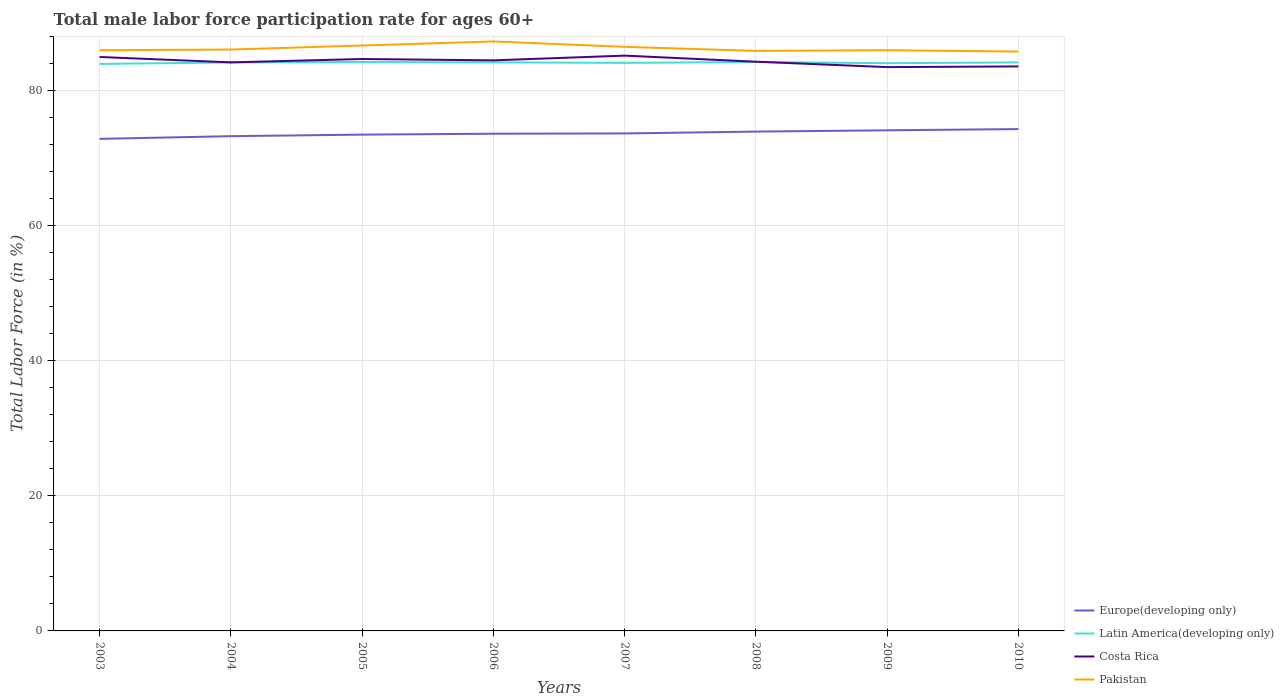How many different coloured lines are there?
Offer a very short reply. 4. Is the number of lines equal to the number of legend labels?
Your answer should be compact. Yes. Across all years, what is the maximum male labor force participation rate in Costa Rica?
Offer a terse response. 83.5. In which year was the male labor force participation rate in Europe(developing only) maximum?
Make the answer very short. 2003. What is the total male labor force participation rate in Pakistan in the graph?
Offer a very short reply. -0.1. What is the difference between the highest and the second highest male labor force participation rate in Latin America(developing only)?
Your answer should be very brief. 0.28. What is the difference between the highest and the lowest male labor force participation rate in Latin America(developing only)?
Provide a succinct answer. 5. Is the male labor force participation rate in Pakistan strictly greater than the male labor force participation rate in Latin America(developing only) over the years?
Give a very brief answer. No. How many lines are there?
Keep it short and to the point. 4. How many years are there in the graph?
Provide a succinct answer. 8. Are the values on the major ticks of Y-axis written in scientific E-notation?
Offer a terse response. No. Does the graph contain grids?
Provide a succinct answer. Yes. Where does the legend appear in the graph?
Provide a succinct answer. Bottom right. What is the title of the graph?
Your response must be concise. Total male labor force participation rate for ages 60+. Does "Europe(all income levels)" appear as one of the legend labels in the graph?
Keep it short and to the point. No. What is the label or title of the Y-axis?
Keep it short and to the point. Total Labor Force (in %). What is the Total Labor Force (in %) in Europe(developing only) in 2003?
Provide a succinct answer. 72.87. What is the Total Labor Force (in %) of Latin America(developing only) in 2003?
Keep it short and to the point. 83.97. What is the Total Labor Force (in %) in Costa Rica in 2003?
Offer a terse response. 85. What is the Total Labor Force (in %) in Europe(developing only) in 2004?
Your answer should be very brief. 73.27. What is the Total Labor Force (in %) of Latin America(developing only) in 2004?
Provide a short and direct response. 84.19. What is the Total Labor Force (in %) in Costa Rica in 2004?
Keep it short and to the point. 84.2. What is the Total Labor Force (in %) in Pakistan in 2004?
Provide a short and direct response. 86.1. What is the Total Labor Force (in %) in Europe(developing only) in 2005?
Provide a succinct answer. 73.5. What is the Total Labor Force (in %) of Latin America(developing only) in 2005?
Keep it short and to the point. 84.25. What is the Total Labor Force (in %) of Costa Rica in 2005?
Make the answer very short. 84.7. What is the Total Labor Force (in %) in Pakistan in 2005?
Your answer should be compact. 86.7. What is the Total Labor Force (in %) in Europe(developing only) in 2006?
Keep it short and to the point. 73.63. What is the Total Labor Force (in %) of Latin America(developing only) in 2006?
Ensure brevity in your answer.  84.2. What is the Total Labor Force (in %) of Costa Rica in 2006?
Make the answer very short. 84.5. What is the Total Labor Force (in %) of Pakistan in 2006?
Your answer should be compact. 87.3. What is the Total Labor Force (in %) in Europe(developing only) in 2007?
Provide a succinct answer. 73.68. What is the Total Labor Force (in %) of Latin America(developing only) in 2007?
Keep it short and to the point. 84.13. What is the Total Labor Force (in %) in Costa Rica in 2007?
Give a very brief answer. 85.2. What is the Total Labor Force (in %) of Pakistan in 2007?
Provide a succinct answer. 86.5. What is the Total Labor Force (in %) of Europe(developing only) in 2008?
Offer a terse response. 73.95. What is the Total Labor Force (in %) of Latin America(developing only) in 2008?
Ensure brevity in your answer.  84.26. What is the Total Labor Force (in %) in Costa Rica in 2008?
Provide a short and direct response. 84.3. What is the Total Labor Force (in %) of Pakistan in 2008?
Your answer should be compact. 85.9. What is the Total Labor Force (in %) of Europe(developing only) in 2009?
Provide a succinct answer. 74.14. What is the Total Labor Force (in %) in Latin America(developing only) in 2009?
Offer a terse response. 84.08. What is the Total Labor Force (in %) of Costa Rica in 2009?
Make the answer very short. 83.5. What is the Total Labor Force (in %) in Europe(developing only) in 2010?
Keep it short and to the point. 74.32. What is the Total Labor Force (in %) of Latin America(developing only) in 2010?
Make the answer very short. 84.2. What is the Total Labor Force (in %) of Costa Rica in 2010?
Make the answer very short. 83.6. What is the Total Labor Force (in %) of Pakistan in 2010?
Ensure brevity in your answer.  85.8. Across all years, what is the maximum Total Labor Force (in %) in Europe(developing only)?
Offer a terse response. 74.32. Across all years, what is the maximum Total Labor Force (in %) of Latin America(developing only)?
Ensure brevity in your answer.  84.26. Across all years, what is the maximum Total Labor Force (in %) of Costa Rica?
Offer a very short reply. 85.2. Across all years, what is the maximum Total Labor Force (in %) in Pakistan?
Your response must be concise. 87.3. Across all years, what is the minimum Total Labor Force (in %) in Europe(developing only)?
Your answer should be compact. 72.87. Across all years, what is the minimum Total Labor Force (in %) in Latin America(developing only)?
Provide a short and direct response. 83.97. Across all years, what is the minimum Total Labor Force (in %) of Costa Rica?
Make the answer very short. 83.5. Across all years, what is the minimum Total Labor Force (in %) of Pakistan?
Ensure brevity in your answer.  85.8. What is the total Total Labor Force (in %) of Europe(developing only) in the graph?
Your answer should be compact. 589.37. What is the total Total Labor Force (in %) of Latin America(developing only) in the graph?
Ensure brevity in your answer.  673.28. What is the total Total Labor Force (in %) in Costa Rica in the graph?
Provide a short and direct response. 675. What is the total Total Labor Force (in %) in Pakistan in the graph?
Ensure brevity in your answer.  690.3. What is the difference between the Total Labor Force (in %) in Europe(developing only) in 2003 and that in 2004?
Your response must be concise. -0.4. What is the difference between the Total Labor Force (in %) of Latin America(developing only) in 2003 and that in 2004?
Give a very brief answer. -0.22. What is the difference between the Total Labor Force (in %) in Europe(developing only) in 2003 and that in 2005?
Ensure brevity in your answer.  -0.63. What is the difference between the Total Labor Force (in %) of Latin America(developing only) in 2003 and that in 2005?
Your answer should be very brief. -0.28. What is the difference between the Total Labor Force (in %) in Costa Rica in 2003 and that in 2005?
Provide a short and direct response. 0.3. What is the difference between the Total Labor Force (in %) of Pakistan in 2003 and that in 2005?
Provide a succinct answer. -0.7. What is the difference between the Total Labor Force (in %) of Europe(developing only) in 2003 and that in 2006?
Give a very brief answer. -0.76. What is the difference between the Total Labor Force (in %) in Latin America(developing only) in 2003 and that in 2006?
Offer a very short reply. -0.23. What is the difference between the Total Labor Force (in %) in Pakistan in 2003 and that in 2006?
Provide a short and direct response. -1.3. What is the difference between the Total Labor Force (in %) of Europe(developing only) in 2003 and that in 2007?
Offer a very short reply. -0.8. What is the difference between the Total Labor Force (in %) in Latin America(developing only) in 2003 and that in 2007?
Offer a very short reply. -0.15. What is the difference between the Total Labor Force (in %) in Costa Rica in 2003 and that in 2007?
Give a very brief answer. -0.2. What is the difference between the Total Labor Force (in %) of Europe(developing only) in 2003 and that in 2008?
Offer a very short reply. -1.08. What is the difference between the Total Labor Force (in %) of Latin America(developing only) in 2003 and that in 2008?
Make the answer very short. -0.28. What is the difference between the Total Labor Force (in %) in Costa Rica in 2003 and that in 2008?
Give a very brief answer. 0.7. What is the difference between the Total Labor Force (in %) of Europe(developing only) in 2003 and that in 2009?
Give a very brief answer. -1.27. What is the difference between the Total Labor Force (in %) of Latin America(developing only) in 2003 and that in 2009?
Make the answer very short. -0.11. What is the difference between the Total Labor Force (in %) of Costa Rica in 2003 and that in 2009?
Provide a short and direct response. 1.5. What is the difference between the Total Labor Force (in %) in Europe(developing only) in 2003 and that in 2010?
Make the answer very short. -1.45. What is the difference between the Total Labor Force (in %) in Latin America(developing only) in 2003 and that in 2010?
Offer a terse response. -0.22. What is the difference between the Total Labor Force (in %) of Pakistan in 2003 and that in 2010?
Keep it short and to the point. 0.2. What is the difference between the Total Labor Force (in %) of Europe(developing only) in 2004 and that in 2005?
Your answer should be compact. -0.23. What is the difference between the Total Labor Force (in %) of Latin America(developing only) in 2004 and that in 2005?
Your answer should be very brief. -0.06. What is the difference between the Total Labor Force (in %) in Costa Rica in 2004 and that in 2005?
Provide a succinct answer. -0.5. What is the difference between the Total Labor Force (in %) in Europe(developing only) in 2004 and that in 2006?
Keep it short and to the point. -0.36. What is the difference between the Total Labor Force (in %) of Latin America(developing only) in 2004 and that in 2006?
Give a very brief answer. -0.01. What is the difference between the Total Labor Force (in %) in Pakistan in 2004 and that in 2006?
Provide a short and direct response. -1.2. What is the difference between the Total Labor Force (in %) in Europe(developing only) in 2004 and that in 2007?
Keep it short and to the point. -0.4. What is the difference between the Total Labor Force (in %) of Latin America(developing only) in 2004 and that in 2007?
Your answer should be compact. 0.06. What is the difference between the Total Labor Force (in %) in Europe(developing only) in 2004 and that in 2008?
Give a very brief answer. -0.68. What is the difference between the Total Labor Force (in %) in Latin America(developing only) in 2004 and that in 2008?
Your answer should be very brief. -0.07. What is the difference between the Total Labor Force (in %) in Europe(developing only) in 2004 and that in 2009?
Provide a short and direct response. -0.87. What is the difference between the Total Labor Force (in %) in Latin America(developing only) in 2004 and that in 2009?
Offer a very short reply. 0.11. What is the difference between the Total Labor Force (in %) of Costa Rica in 2004 and that in 2009?
Provide a short and direct response. 0.7. What is the difference between the Total Labor Force (in %) of Europe(developing only) in 2004 and that in 2010?
Your response must be concise. -1.05. What is the difference between the Total Labor Force (in %) in Latin America(developing only) in 2004 and that in 2010?
Your response must be concise. -0.01. What is the difference between the Total Labor Force (in %) of Pakistan in 2004 and that in 2010?
Your answer should be compact. 0.3. What is the difference between the Total Labor Force (in %) in Europe(developing only) in 2005 and that in 2006?
Make the answer very short. -0.13. What is the difference between the Total Labor Force (in %) in Latin America(developing only) in 2005 and that in 2006?
Provide a succinct answer. 0.05. What is the difference between the Total Labor Force (in %) in Costa Rica in 2005 and that in 2006?
Give a very brief answer. 0.2. What is the difference between the Total Labor Force (in %) of Europe(developing only) in 2005 and that in 2007?
Your response must be concise. -0.17. What is the difference between the Total Labor Force (in %) in Latin America(developing only) in 2005 and that in 2007?
Keep it short and to the point. 0.13. What is the difference between the Total Labor Force (in %) in Europe(developing only) in 2005 and that in 2008?
Ensure brevity in your answer.  -0.45. What is the difference between the Total Labor Force (in %) in Latin America(developing only) in 2005 and that in 2008?
Make the answer very short. -0. What is the difference between the Total Labor Force (in %) in Pakistan in 2005 and that in 2008?
Your answer should be compact. 0.8. What is the difference between the Total Labor Force (in %) in Europe(developing only) in 2005 and that in 2009?
Offer a terse response. -0.64. What is the difference between the Total Labor Force (in %) of Latin America(developing only) in 2005 and that in 2009?
Your response must be concise. 0.17. What is the difference between the Total Labor Force (in %) of Pakistan in 2005 and that in 2009?
Offer a terse response. 0.7. What is the difference between the Total Labor Force (in %) in Europe(developing only) in 2005 and that in 2010?
Offer a very short reply. -0.82. What is the difference between the Total Labor Force (in %) of Latin America(developing only) in 2005 and that in 2010?
Ensure brevity in your answer.  0.06. What is the difference between the Total Labor Force (in %) of Costa Rica in 2005 and that in 2010?
Ensure brevity in your answer.  1.1. What is the difference between the Total Labor Force (in %) of Pakistan in 2005 and that in 2010?
Keep it short and to the point. 0.9. What is the difference between the Total Labor Force (in %) in Europe(developing only) in 2006 and that in 2007?
Offer a terse response. -0.04. What is the difference between the Total Labor Force (in %) of Latin America(developing only) in 2006 and that in 2007?
Ensure brevity in your answer.  0.08. What is the difference between the Total Labor Force (in %) of Pakistan in 2006 and that in 2007?
Provide a short and direct response. 0.8. What is the difference between the Total Labor Force (in %) in Europe(developing only) in 2006 and that in 2008?
Provide a succinct answer. -0.32. What is the difference between the Total Labor Force (in %) in Latin America(developing only) in 2006 and that in 2008?
Offer a very short reply. -0.05. What is the difference between the Total Labor Force (in %) of Pakistan in 2006 and that in 2008?
Offer a terse response. 1.4. What is the difference between the Total Labor Force (in %) in Europe(developing only) in 2006 and that in 2009?
Keep it short and to the point. -0.51. What is the difference between the Total Labor Force (in %) of Latin America(developing only) in 2006 and that in 2009?
Keep it short and to the point. 0.12. What is the difference between the Total Labor Force (in %) in Pakistan in 2006 and that in 2009?
Your answer should be very brief. 1.3. What is the difference between the Total Labor Force (in %) in Europe(developing only) in 2006 and that in 2010?
Make the answer very short. -0.69. What is the difference between the Total Labor Force (in %) in Latin America(developing only) in 2006 and that in 2010?
Keep it short and to the point. 0.01. What is the difference between the Total Labor Force (in %) in Europe(developing only) in 2007 and that in 2008?
Provide a succinct answer. -0.27. What is the difference between the Total Labor Force (in %) in Latin America(developing only) in 2007 and that in 2008?
Keep it short and to the point. -0.13. What is the difference between the Total Labor Force (in %) of Costa Rica in 2007 and that in 2008?
Your response must be concise. 0.9. What is the difference between the Total Labor Force (in %) of Pakistan in 2007 and that in 2008?
Offer a terse response. 0.6. What is the difference between the Total Labor Force (in %) of Europe(developing only) in 2007 and that in 2009?
Provide a succinct answer. -0.47. What is the difference between the Total Labor Force (in %) in Latin America(developing only) in 2007 and that in 2009?
Your answer should be very brief. 0.05. What is the difference between the Total Labor Force (in %) in Costa Rica in 2007 and that in 2009?
Your response must be concise. 1.7. What is the difference between the Total Labor Force (in %) in Europe(developing only) in 2007 and that in 2010?
Provide a succinct answer. -0.64. What is the difference between the Total Labor Force (in %) of Latin America(developing only) in 2007 and that in 2010?
Make the answer very short. -0.07. What is the difference between the Total Labor Force (in %) in Pakistan in 2007 and that in 2010?
Give a very brief answer. 0.7. What is the difference between the Total Labor Force (in %) of Europe(developing only) in 2008 and that in 2009?
Ensure brevity in your answer.  -0.19. What is the difference between the Total Labor Force (in %) in Latin America(developing only) in 2008 and that in 2009?
Your response must be concise. 0.18. What is the difference between the Total Labor Force (in %) of Costa Rica in 2008 and that in 2009?
Offer a very short reply. 0.8. What is the difference between the Total Labor Force (in %) of Pakistan in 2008 and that in 2009?
Keep it short and to the point. -0.1. What is the difference between the Total Labor Force (in %) in Europe(developing only) in 2008 and that in 2010?
Your answer should be compact. -0.37. What is the difference between the Total Labor Force (in %) of Latin America(developing only) in 2008 and that in 2010?
Make the answer very short. 0.06. What is the difference between the Total Labor Force (in %) in Pakistan in 2008 and that in 2010?
Provide a short and direct response. 0.1. What is the difference between the Total Labor Force (in %) of Europe(developing only) in 2009 and that in 2010?
Your answer should be compact. -0.18. What is the difference between the Total Labor Force (in %) in Latin America(developing only) in 2009 and that in 2010?
Make the answer very short. -0.12. What is the difference between the Total Labor Force (in %) of Costa Rica in 2009 and that in 2010?
Offer a terse response. -0.1. What is the difference between the Total Labor Force (in %) in Europe(developing only) in 2003 and the Total Labor Force (in %) in Latin America(developing only) in 2004?
Provide a succinct answer. -11.32. What is the difference between the Total Labor Force (in %) of Europe(developing only) in 2003 and the Total Labor Force (in %) of Costa Rica in 2004?
Your answer should be compact. -11.33. What is the difference between the Total Labor Force (in %) in Europe(developing only) in 2003 and the Total Labor Force (in %) in Pakistan in 2004?
Offer a terse response. -13.23. What is the difference between the Total Labor Force (in %) of Latin America(developing only) in 2003 and the Total Labor Force (in %) of Costa Rica in 2004?
Your response must be concise. -0.23. What is the difference between the Total Labor Force (in %) of Latin America(developing only) in 2003 and the Total Labor Force (in %) of Pakistan in 2004?
Provide a short and direct response. -2.13. What is the difference between the Total Labor Force (in %) in Costa Rica in 2003 and the Total Labor Force (in %) in Pakistan in 2004?
Your answer should be compact. -1.1. What is the difference between the Total Labor Force (in %) in Europe(developing only) in 2003 and the Total Labor Force (in %) in Latin America(developing only) in 2005?
Your response must be concise. -11.38. What is the difference between the Total Labor Force (in %) in Europe(developing only) in 2003 and the Total Labor Force (in %) in Costa Rica in 2005?
Your answer should be very brief. -11.83. What is the difference between the Total Labor Force (in %) in Europe(developing only) in 2003 and the Total Labor Force (in %) in Pakistan in 2005?
Ensure brevity in your answer.  -13.83. What is the difference between the Total Labor Force (in %) of Latin America(developing only) in 2003 and the Total Labor Force (in %) of Costa Rica in 2005?
Make the answer very short. -0.73. What is the difference between the Total Labor Force (in %) in Latin America(developing only) in 2003 and the Total Labor Force (in %) in Pakistan in 2005?
Keep it short and to the point. -2.73. What is the difference between the Total Labor Force (in %) of Europe(developing only) in 2003 and the Total Labor Force (in %) of Latin America(developing only) in 2006?
Your response must be concise. -11.33. What is the difference between the Total Labor Force (in %) in Europe(developing only) in 2003 and the Total Labor Force (in %) in Costa Rica in 2006?
Offer a very short reply. -11.63. What is the difference between the Total Labor Force (in %) of Europe(developing only) in 2003 and the Total Labor Force (in %) of Pakistan in 2006?
Ensure brevity in your answer.  -14.43. What is the difference between the Total Labor Force (in %) in Latin America(developing only) in 2003 and the Total Labor Force (in %) in Costa Rica in 2006?
Your answer should be very brief. -0.53. What is the difference between the Total Labor Force (in %) of Latin America(developing only) in 2003 and the Total Labor Force (in %) of Pakistan in 2006?
Provide a succinct answer. -3.33. What is the difference between the Total Labor Force (in %) in Europe(developing only) in 2003 and the Total Labor Force (in %) in Latin America(developing only) in 2007?
Keep it short and to the point. -11.25. What is the difference between the Total Labor Force (in %) in Europe(developing only) in 2003 and the Total Labor Force (in %) in Costa Rica in 2007?
Keep it short and to the point. -12.33. What is the difference between the Total Labor Force (in %) in Europe(developing only) in 2003 and the Total Labor Force (in %) in Pakistan in 2007?
Make the answer very short. -13.63. What is the difference between the Total Labor Force (in %) of Latin America(developing only) in 2003 and the Total Labor Force (in %) of Costa Rica in 2007?
Make the answer very short. -1.23. What is the difference between the Total Labor Force (in %) of Latin America(developing only) in 2003 and the Total Labor Force (in %) of Pakistan in 2007?
Provide a short and direct response. -2.53. What is the difference between the Total Labor Force (in %) of Europe(developing only) in 2003 and the Total Labor Force (in %) of Latin America(developing only) in 2008?
Offer a very short reply. -11.38. What is the difference between the Total Labor Force (in %) of Europe(developing only) in 2003 and the Total Labor Force (in %) of Costa Rica in 2008?
Make the answer very short. -11.43. What is the difference between the Total Labor Force (in %) of Europe(developing only) in 2003 and the Total Labor Force (in %) of Pakistan in 2008?
Your answer should be very brief. -13.03. What is the difference between the Total Labor Force (in %) in Latin America(developing only) in 2003 and the Total Labor Force (in %) in Costa Rica in 2008?
Your answer should be very brief. -0.33. What is the difference between the Total Labor Force (in %) in Latin America(developing only) in 2003 and the Total Labor Force (in %) in Pakistan in 2008?
Your answer should be very brief. -1.93. What is the difference between the Total Labor Force (in %) of Costa Rica in 2003 and the Total Labor Force (in %) of Pakistan in 2008?
Your answer should be very brief. -0.9. What is the difference between the Total Labor Force (in %) in Europe(developing only) in 2003 and the Total Labor Force (in %) in Latin America(developing only) in 2009?
Give a very brief answer. -11.21. What is the difference between the Total Labor Force (in %) in Europe(developing only) in 2003 and the Total Labor Force (in %) in Costa Rica in 2009?
Ensure brevity in your answer.  -10.63. What is the difference between the Total Labor Force (in %) in Europe(developing only) in 2003 and the Total Labor Force (in %) in Pakistan in 2009?
Provide a short and direct response. -13.13. What is the difference between the Total Labor Force (in %) in Latin America(developing only) in 2003 and the Total Labor Force (in %) in Costa Rica in 2009?
Your response must be concise. 0.47. What is the difference between the Total Labor Force (in %) of Latin America(developing only) in 2003 and the Total Labor Force (in %) of Pakistan in 2009?
Give a very brief answer. -2.03. What is the difference between the Total Labor Force (in %) of Europe(developing only) in 2003 and the Total Labor Force (in %) of Latin America(developing only) in 2010?
Offer a very short reply. -11.32. What is the difference between the Total Labor Force (in %) in Europe(developing only) in 2003 and the Total Labor Force (in %) in Costa Rica in 2010?
Make the answer very short. -10.73. What is the difference between the Total Labor Force (in %) in Europe(developing only) in 2003 and the Total Labor Force (in %) in Pakistan in 2010?
Your answer should be very brief. -12.93. What is the difference between the Total Labor Force (in %) in Latin America(developing only) in 2003 and the Total Labor Force (in %) in Costa Rica in 2010?
Your response must be concise. 0.37. What is the difference between the Total Labor Force (in %) of Latin America(developing only) in 2003 and the Total Labor Force (in %) of Pakistan in 2010?
Give a very brief answer. -1.83. What is the difference between the Total Labor Force (in %) of Costa Rica in 2003 and the Total Labor Force (in %) of Pakistan in 2010?
Make the answer very short. -0.8. What is the difference between the Total Labor Force (in %) in Europe(developing only) in 2004 and the Total Labor Force (in %) in Latin America(developing only) in 2005?
Offer a terse response. -10.98. What is the difference between the Total Labor Force (in %) in Europe(developing only) in 2004 and the Total Labor Force (in %) in Costa Rica in 2005?
Offer a terse response. -11.43. What is the difference between the Total Labor Force (in %) in Europe(developing only) in 2004 and the Total Labor Force (in %) in Pakistan in 2005?
Offer a terse response. -13.43. What is the difference between the Total Labor Force (in %) of Latin America(developing only) in 2004 and the Total Labor Force (in %) of Costa Rica in 2005?
Offer a very short reply. -0.51. What is the difference between the Total Labor Force (in %) in Latin America(developing only) in 2004 and the Total Labor Force (in %) in Pakistan in 2005?
Provide a succinct answer. -2.51. What is the difference between the Total Labor Force (in %) in Europe(developing only) in 2004 and the Total Labor Force (in %) in Latin America(developing only) in 2006?
Offer a terse response. -10.93. What is the difference between the Total Labor Force (in %) of Europe(developing only) in 2004 and the Total Labor Force (in %) of Costa Rica in 2006?
Offer a terse response. -11.23. What is the difference between the Total Labor Force (in %) of Europe(developing only) in 2004 and the Total Labor Force (in %) of Pakistan in 2006?
Your answer should be very brief. -14.03. What is the difference between the Total Labor Force (in %) in Latin America(developing only) in 2004 and the Total Labor Force (in %) in Costa Rica in 2006?
Give a very brief answer. -0.31. What is the difference between the Total Labor Force (in %) of Latin America(developing only) in 2004 and the Total Labor Force (in %) of Pakistan in 2006?
Keep it short and to the point. -3.11. What is the difference between the Total Labor Force (in %) in Europe(developing only) in 2004 and the Total Labor Force (in %) in Latin America(developing only) in 2007?
Offer a terse response. -10.85. What is the difference between the Total Labor Force (in %) of Europe(developing only) in 2004 and the Total Labor Force (in %) of Costa Rica in 2007?
Your answer should be very brief. -11.93. What is the difference between the Total Labor Force (in %) in Europe(developing only) in 2004 and the Total Labor Force (in %) in Pakistan in 2007?
Your answer should be compact. -13.23. What is the difference between the Total Labor Force (in %) in Latin America(developing only) in 2004 and the Total Labor Force (in %) in Costa Rica in 2007?
Give a very brief answer. -1.01. What is the difference between the Total Labor Force (in %) in Latin America(developing only) in 2004 and the Total Labor Force (in %) in Pakistan in 2007?
Keep it short and to the point. -2.31. What is the difference between the Total Labor Force (in %) of Europe(developing only) in 2004 and the Total Labor Force (in %) of Latin America(developing only) in 2008?
Give a very brief answer. -10.99. What is the difference between the Total Labor Force (in %) in Europe(developing only) in 2004 and the Total Labor Force (in %) in Costa Rica in 2008?
Provide a succinct answer. -11.03. What is the difference between the Total Labor Force (in %) in Europe(developing only) in 2004 and the Total Labor Force (in %) in Pakistan in 2008?
Offer a terse response. -12.63. What is the difference between the Total Labor Force (in %) of Latin America(developing only) in 2004 and the Total Labor Force (in %) of Costa Rica in 2008?
Provide a short and direct response. -0.11. What is the difference between the Total Labor Force (in %) in Latin America(developing only) in 2004 and the Total Labor Force (in %) in Pakistan in 2008?
Offer a very short reply. -1.71. What is the difference between the Total Labor Force (in %) of Europe(developing only) in 2004 and the Total Labor Force (in %) of Latin America(developing only) in 2009?
Offer a very short reply. -10.81. What is the difference between the Total Labor Force (in %) of Europe(developing only) in 2004 and the Total Labor Force (in %) of Costa Rica in 2009?
Your response must be concise. -10.23. What is the difference between the Total Labor Force (in %) in Europe(developing only) in 2004 and the Total Labor Force (in %) in Pakistan in 2009?
Provide a succinct answer. -12.73. What is the difference between the Total Labor Force (in %) of Latin America(developing only) in 2004 and the Total Labor Force (in %) of Costa Rica in 2009?
Give a very brief answer. 0.69. What is the difference between the Total Labor Force (in %) in Latin America(developing only) in 2004 and the Total Labor Force (in %) in Pakistan in 2009?
Ensure brevity in your answer.  -1.81. What is the difference between the Total Labor Force (in %) of Europe(developing only) in 2004 and the Total Labor Force (in %) of Latin America(developing only) in 2010?
Keep it short and to the point. -10.92. What is the difference between the Total Labor Force (in %) in Europe(developing only) in 2004 and the Total Labor Force (in %) in Costa Rica in 2010?
Give a very brief answer. -10.33. What is the difference between the Total Labor Force (in %) in Europe(developing only) in 2004 and the Total Labor Force (in %) in Pakistan in 2010?
Your answer should be very brief. -12.53. What is the difference between the Total Labor Force (in %) of Latin America(developing only) in 2004 and the Total Labor Force (in %) of Costa Rica in 2010?
Make the answer very short. 0.59. What is the difference between the Total Labor Force (in %) of Latin America(developing only) in 2004 and the Total Labor Force (in %) of Pakistan in 2010?
Ensure brevity in your answer.  -1.61. What is the difference between the Total Labor Force (in %) in Europe(developing only) in 2005 and the Total Labor Force (in %) in Latin America(developing only) in 2006?
Ensure brevity in your answer.  -10.7. What is the difference between the Total Labor Force (in %) of Europe(developing only) in 2005 and the Total Labor Force (in %) of Costa Rica in 2006?
Make the answer very short. -11. What is the difference between the Total Labor Force (in %) of Europe(developing only) in 2005 and the Total Labor Force (in %) of Pakistan in 2006?
Your answer should be very brief. -13.8. What is the difference between the Total Labor Force (in %) in Latin America(developing only) in 2005 and the Total Labor Force (in %) in Costa Rica in 2006?
Make the answer very short. -0.25. What is the difference between the Total Labor Force (in %) of Latin America(developing only) in 2005 and the Total Labor Force (in %) of Pakistan in 2006?
Your response must be concise. -3.05. What is the difference between the Total Labor Force (in %) in Europe(developing only) in 2005 and the Total Labor Force (in %) in Latin America(developing only) in 2007?
Your answer should be very brief. -10.62. What is the difference between the Total Labor Force (in %) of Europe(developing only) in 2005 and the Total Labor Force (in %) of Costa Rica in 2007?
Provide a succinct answer. -11.7. What is the difference between the Total Labor Force (in %) of Europe(developing only) in 2005 and the Total Labor Force (in %) of Pakistan in 2007?
Offer a terse response. -13. What is the difference between the Total Labor Force (in %) of Latin America(developing only) in 2005 and the Total Labor Force (in %) of Costa Rica in 2007?
Keep it short and to the point. -0.95. What is the difference between the Total Labor Force (in %) in Latin America(developing only) in 2005 and the Total Labor Force (in %) in Pakistan in 2007?
Your answer should be very brief. -2.25. What is the difference between the Total Labor Force (in %) in Costa Rica in 2005 and the Total Labor Force (in %) in Pakistan in 2007?
Provide a short and direct response. -1.8. What is the difference between the Total Labor Force (in %) in Europe(developing only) in 2005 and the Total Labor Force (in %) in Latin America(developing only) in 2008?
Your answer should be compact. -10.76. What is the difference between the Total Labor Force (in %) of Europe(developing only) in 2005 and the Total Labor Force (in %) of Costa Rica in 2008?
Offer a terse response. -10.8. What is the difference between the Total Labor Force (in %) of Europe(developing only) in 2005 and the Total Labor Force (in %) of Pakistan in 2008?
Your answer should be compact. -12.4. What is the difference between the Total Labor Force (in %) of Latin America(developing only) in 2005 and the Total Labor Force (in %) of Costa Rica in 2008?
Offer a very short reply. -0.05. What is the difference between the Total Labor Force (in %) of Latin America(developing only) in 2005 and the Total Labor Force (in %) of Pakistan in 2008?
Ensure brevity in your answer.  -1.65. What is the difference between the Total Labor Force (in %) in Europe(developing only) in 2005 and the Total Labor Force (in %) in Latin America(developing only) in 2009?
Your answer should be very brief. -10.58. What is the difference between the Total Labor Force (in %) in Europe(developing only) in 2005 and the Total Labor Force (in %) in Costa Rica in 2009?
Ensure brevity in your answer.  -10. What is the difference between the Total Labor Force (in %) in Europe(developing only) in 2005 and the Total Labor Force (in %) in Pakistan in 2009?
Provide a succinct answer. -12.5. What is the difference between the Total Labor Force (in %) of Latin America(developing only) in 2005 and the Total Labor Force (in %) of Costa Rica in 2009?
Provide a succinct answer. 0.75. What is the difference between the Total Labor Force (in %) in Latin America(developing only) in 2005 and the Total Labor Force (in %) in Pakistan in 2009?
Keep it short and to the point. -1.75. What is the difference between the Total Labor Force (in %) in Europe(developing only) in 2005 and the Total Labor Force (in %) in Latin America(developing only) in 2010?
Provide a short and direct response. -10.7. What is the difference between the Total Labor Force (in %) in Europe(developing only) in 2005 and the Total Labor Force (in %) in Costa Rica in 2010?
Provide a succinct answer. -10.1. What is the difference between the Total Labor Force (in %) of Europe(developing only) in 2005 and the Total Labor Force (in %) of Pakistan in 2010?
Your response must be concise. -12.3. What is the difference between the Total Labor Force (in %) of Latin America(developing only) in 2005 and the Total Labor Force (in %) of Costa Rica in 2010?
Provide a short and direct response. 0.65. What is the difference between the Total Labor Force (in %) of Latin America(developing only) in 2005 and the Total Labor Force (in %) of Pakistan in 2010?
Your answer should be very brief. -1.55. What is the difference between the Total Labor Force (in %) in Europe(developing only) in 2006 and the Total Labor Force (in %) in Latin America(developing only) in 2007?
Ensure brevity in your answer.  -10.49. What is the difference between the Total Labor Force (in %) of Europe(developing only) in 2006 and the Total Labor Force (in %) of Costa Rica in 2007?
Provide a succinct answer. -11.57. What is the difference between the Total Labor Force (in %) in Europe(developing only) in 2006 and the Total Labor Force (in %) in Pakistan in 2007?
Your answer should be very brief. -12.87. What is the difference between the Total Labor Force (in %) in Latin America(developing only) in 2006 and the Total Labor Force (in %) in Costa Rica in 2007?
Your response must be concise. -1. What is the difference between the Total Labor Force (in %) of Latin America(developing only) in 2006 and the Total Labor Force (in %) of Pakistan in 2007?
Make the answer very short. -2.3. What is the difference between the Total Labor Force (in %) of Europe(developing only) in 2006 and the Total Labor Force (in %) of Latin America(developing only) in 2008?
Your answer should be very brief. -10.62. What is the difference between the Total Labor Force (in %) of Europe(developing only) in 2006 and the Total Labor Force (in %) of Costa Rica in 2008?
Provide a succinct answer. -10.67. What is the difference between the Total Labor Force (in %) in Europe(developing only) in 2006 and the Total Labor Force (in %) in Pakistan in 2008?
Offer a very short reply. -12.27. What is the difference between the Total Labor Force (in %) in Latin America(developing only) in 2006 and the Total Labor Force (in %) in Costa Rica in 2008?
Your answer should be very brief. -0.1. What is the difference between the Total Labor Force (in %) in Latin America(developing only) in 2006 and the Total Labor Force (in %) in Pakistan in 2008?
Your response must be concise. -1.7. What is the difference between the Total Labor Force (in %) of Europe(developing only) in 2006 and the Total Labor Force (in %) of Latin America(developing only) in 2009?
Your answer should be very brief. -10.44. What is the difference between the Total Labor Force (in %) of Europe(developing only) in 2006 and the Total Labor Force (in %) of Costa Rica in 2009?
Give a very brief answer. -9.87. What is the difference between the Total Labor Force (in %) of Europe(developing only) in 2006 and the Total Labor Force (in %) of Pakistan in 2009?
Your answer should be compact. -12.37. What is the difference between the Total Labor Force (in %) of Latin America(developing only) in 2006 and the Total Labor Force (in %) of Costa Rica in 2009?
Your response must be concise. 0.7. What is the difference between the Total Labor Force (in %) of Latin America(developing only) in 2006 and the Total Labor Force (in %) of Pakistan in 2009?
Keep it short and to the point. -1.8. What is the difference between the Total Labor Force (in %) in Europe(developing only) in 2006 and the Total Labor Force (in %) in Latin America(developing only) in 2010?
Offer a very short reply. -10.56. What is the difference between the Total Labor Force (in %) in Europe(developing only) in 2006 and the Total Labor Force (in %) in Costa Rica in 2010?
Offer a terse response. -9.97. What is the difference between the Total Labor Force (in %) in Europe(developing only) in 2006 and the Total Labor Force (in %) in Pakistan in 2010?
Ensure brevity in your answer.  -12.17. What is the difference between the Total Labor Force (in %) of Latin America(developing only) in 2006 and the Total Labor Force (in %) of Costa Rica in 2010?
Provide a short and direct response. 0.6. What is the difference between the Total Labor Force (in %) of Latin America(developing only) in 2006 and the Total Labor Force (in %) of Pakistan in 2010?
Offer a terse response. -1.6. What is the difference between the Total Labor Force (in %) of Europe(developing only) in 2007 and the Total Labor Force (in %) of Latin America(developing only) in 2008?
Offer a terse response. -10.58. What is the difference between the Total Labor Force (in %) of Europe(developing only) in 2007 and the Total Labor Force (in %) of Costa Rica in 2008?
Your answer should be compact. -10.62. What is the difference between the Total Labor Force (in %) in Europe(developing only) in 2007 and the Total Labor Force (in %) in Pakistan in 2008?
Offer a terse response. -12.22. What is the difference between the Total Labor Force (in %) in Latin America(developing only) in 2007 and the Total Labor Force (in %) in Costa Rica in 2008?
Offer a very short reply. -0.17. What is the difference between the Total Labor Force (in %) of Latin America(developing only) in 2007 and the Total Labor Force (in %) of Pakistan in 2008?
Provide a short and direct response. -1.77. What is the difference between the Total Labor Force (in %) in Europe(developing only) in 2007 and the Total Labor Force (in %) in Latin America(developing only) in 2009?
Make the answer very short. -10.4. What is the difference between the Total Labor Force (in %) in Europe(developing only) in 2007 and the Total Labor Force (in %) in Costa Rica in 2009?
Keep it short and to the point. -9.82. What is the difference between the Total Labor Force (in %) in Europe(developing only) in 2007 and the Total Labor Force (in %) in Pakistan in 2009?
Your response must be concise. -12.32. What is the difference between the Total Labor Force (in %) in Latin America(developing only) in 2007 and the Total Labor Force (in %) in Costa Rica in 2009?
Provide a short and direct response. 0.63. What is the difference between the Total Labor Force (in %) of Latin America(developing only) in 2007 and the Total Labor Force (in %) of Pakistan in 2009?
Ensure brevity in your answer.  -1.87. What is the difference between the Total Labor Force (in %) of Costa Rica in 2007 and the Total Labor Force (in %) of Pakistan in 2009?
Make the answer very short. -0.8. What is the difference between the Total Labor Force (in %) in Europe(developing only) in 2007 and the Total Labor Force (in %) in Latin America(developing only) in 2010?
Your answer should be very brief. -10.52. What is the difference between the Total Labor Force (in %) of Europe(developing only) in 2007 and the Total Labor Force (in %) of Costa Rica in 2010?
Your response must be concise. -9.92. What is the difference between the Total Labor Force (in %) of Europe(developing only) in 2007 and the Total Labor Force (in %) of Pakistan in 2010?
Offer a very short reply. -12.12. What is the difference between the Total Labor Force (in %) in Latin America(developing only) in 2007 and the Total Labor Force (in %) in Costa Rica in 2010?
Your response must be concise. 0.53. What is the difference between the Total Labor Force (in %) of Latin America(developing only) in 2007 and the Total Labor Force (in %) of Pakistan in 2010?
Offer a very short reply. -1.67. What is the difference between the Total Labor Force (in %) of Costa Rica in 2007 and the Total Labor Force (in %) of Pakistan in 2010?
Your answer should be very brief. -0.6. What is the difference between the Total Labor Force (in %) in Europe(developing only) in 2008 and the Total Labor Force (in %) in Latin America(developing only) in 2009?
Offer a very short reply. -10.13. What is the difference between the Total Labor Force (in %) in Europe(developing only) in 2008 and the Total Labor Force (in %) in Costa Rica in 2009?
Your answer should be compact. -9.55. What is the difference between the Total Labor Force (in %) in Europe(developing only) in 2008 and the Total Labor Force (in %) in Pakistan in 2009?
Make the answer very short. -12.05. What is the difference between the Total Labor Force (in %) in Latin America(developing only) in 2008 and the Total Labor Force (in %) in Costa Rica in 2009?
Keep it short and to the point. 0.76. What is the difference between the Total Labor Force (in %) in Latin America(developing only) in 2008 and the Total Labor Force (in %) in Pakistan in 2009?
Provide a succinct answer. -1.74. What is the difference between the Total Labor Force (in %) of Costa Rica in 2008 and the Total Labor Force (in %) of Pakistan in 2009?
Ensure brevity in your answer.  -1.7. What is the difference between the Total Labor Force (in %) of Europe(developing only) in 2008 and the Total Labor Force (in %) of Latin America(developing only) in 2010?
Ensure brevity in your answer.  -10.25. What is the difference between the Total Labor Force (in %) in Europe(developing only) in 2008 and the Total Labor Force (in %) in Costa Rica in 2010?
Offer a very short reply. -9.65. What is the difference between the Total Labor Force (in %) in Europe(developing only) in 2008 and the Total Labor Force (in %) in Pakistan in 2010?
Ensure brevity in your answer.  -11.85. What is the difference between the Total Labor Force (in %) of Latin America(developing only) in 2008 and the Total Labor Force (in %) of Costa Rica in 2010?
Offer a very short reply. 0.66. What is the difference between the Total Labor Force (in %) in Latin America(developing only) in 2008 and the Total Labor Force (in %) in Pakistan in 2010?
Your answer should be very brief. -1.54. What is the difference between the Total Labor Force (in %) of Europe(developing only) in 2009 and the Total Labor Force (in %) of Latin America(developing only) in 2010?
Your response must be concise. -10.05. What is the difference between the Total Labor Force (in %) of Europe(developing only) in 2009 and the Total Labor Force (in %) of Costa Rica in 2010?
Your response must be concise. -9.46. What is the difference between the Total Labor Force (in %) of Europe(developing only) in 2009 and the Total Labor Force (in %) of Pakistan in 2010?
Provide a short and direct response. -11.66. What is the difference between the Total Labor Force (in %) in Latin America(developing only) in 2009 and the Total Labor Force (in %) in Costa Rica in 2010?
Ensure brevity in your answer.  0.48. What is the difference between the Total Labor Force (in %) in Latin America(developing only) in 2009 and the Total Labor Force (in %) in Pakistan in 2010?
Provide a short and direct response. -1.72. What is the difference between the Total Labor Force (in %) in Costa Rica in 2009 and the Total Labor Force (in %) in Pakistan in 2010?
Your response must be concise. -2.3. What is the average Total Labor Force (in %) in Europe(developing only) per year?
Offer a terse response. 73.67. What is the average Total Labor Force (in %) in Latin America(developing only) per year?
Provide a succinct answer. 84.16. What is the average Total Labor Force (in %) of Costa Rica per year?
Offer a terse response. 84.38. What is the average Total Labor Force (in %) of Pakistan per year?
Your answer should be compact. 86.29. In the year 2003, what is the difference between the Total Labor Force (in %) of Europe(developing only) and Total Labor Force (in %) of Costa Rica?
Your answer should be compact. -12.13. In the year 2003, what is the difference between the Total Labor Force (in %) in Europe(developing only) and Total Labor Force (in %) in Pakistan?
Provide a succinct answer. -13.13. In the year 2003, what is the difference between the Total Labor Force (in %) in Latin America(developing only) and Total Labor Force (in %) in Costa Rica?
Give a very brief answer. -1.03. In the year 2003, what is the difference between the Total Labor Force (in %) of Latin America(developing only) and Total Labor Force (in %) of Pakistan?
Keep it short and to the point. -2.03. In the year 2003, what is the difference between the Total Labor Force (in %) in Costa Rica and Total Labor Force (in %) in Pakistan?
Offer a terse response. -1. In the year 2004, what is the difference between the Total Labor Force (in %) of Europe(developing only) and Total Labor Force (in %) of Latin America(developing only)?
Make the answer very short. -10.92. In the year 2004, what is the difference between the Total Labor Force (in %) in Europe(developing only) and Total Labor Force (in %) in Costa Rica?
Ensure brevity in your answer.  -10.93. In the year 2004, what is the difference between the Total Labor Force (in %) of Europe(developing only) and Total Labor Force (in %) of Pakistan?
Provide a short and direct response. -12.83. In the year 2004, what is the difference between the Total Labor Force (in %) of Latin America(developing only) and Total Labor Force (in %) of Costa Rica?
Your answer should be compact. -0.01. In the year 2004, what is the difference between the Total Labor Force (in %) in Latin America(developing only) and Total Labor Force (in %) in Pakistan?
Ensure brevity in your answer.  -1.91. In the year 2004, what is the difference between the Total Labor Force (in %) in Costa Rica and Total Labor Force (in %) in Pakistan?
Your answer should be very brief. -1.9. In the year 2005, what is the difference between the Total Labor Force (in %) of Europe(developing only) and Total Labor Force (in %) of Latin America(developing only)?
Keep it short and to the point. -10.75. In the year 2005, what is the difference between the Total Labor Force (in %) of Europe(developing only) and Total Labor Force (in %) of Costa Rica?
Make the answer very short. -11.2. In the year 2005, what is the difference between the Total Labor Force (in %) of Europe(developing only) and Total Labor Force (in %) of Pakistan?
Give a very brief answer. -13.2. In the year 2005, what is the difference between the Total Labor Force (in %) of Latin America(developing only) and Total Labor Force (in %) of Costa Rica?
Offer a very short reply. -0.45. In the year 2005, what is the difference between the Total Labor Force (in %) in Latin America(developing only) and Total Labor Force (in %) in Pakistan?
Give a very brief answer. -2.45. In the year 2005, what is the difference between the Total Labor Force (in %) of Costa Rica and Total Labor Force (in %) of Pakistan?
Your answer should be compact. -2. In the year 2006, what is the difference between the Total Labor Force (in %) of Europe(developing only) and Total Labor Force (in %) of Latin America(developing only)?
Offer a very short reply. -10.57. In the year 2006, what is the difference between the Total Labor Force (in %) of Europe(developing only) and Total Labor Force (in %) of Costa Rica?
Your answer should be compact. -10.87. In the year 2006, what is the difference between the Total Labor Force (in %) in Europe(developing only) and Total Labor Force (in %) in Pakistan?
Offer a terse response. -13.67. In the year 2006, what is the difference between the Total Labor Force (in %) of Latin America(developing only) and Total Labor Force (in %) of Costa Rica?
Give a very brief answer. -0.3. In the year 2006, what is the difference between the Total Labor Force (in %) in Latin America(developing only) and Total Labor Force (in %) in Pakistan?
Provide a short and direct response. -3.1. In the year 2006, what is the difference between the Total Labor Force (in %) of Costa Rica and Total Labor Force (in %) of Pakistan?
Offer a terse response. -2.8. In the year 2007, what is the difference between the Total Labor Force (in %) in Europe(developing only) and Total Labor Force (in %) in Latin America(developing only)?
Your response must be concise. -10.45. In the year 2007, what is the difference between the Total Labor Force (in %) of Europe(developing only) and Total Labor Force (in %) of Costa Rica?
Provide a short and direct response. -11.52. In the year 2007, what is the difference between the Total Labor Force (in %) in Europe(developing only) and Total Labor Force (in %) in Pakistan?
Ensure brevity in your answer.  -12.82. In the year 2007, what is the difference between the Total Labor Force (in %) of Latin America(developing only) and Total Labor Force (in %) of Costa Rica?
Provide a short and direct response. -1.07. In the year 2007, what is the difference between the Total Labor Force (in %) in Latin America(developing only) and Total Labor Force (in %) in Pakistan?
Offer a terse response. -2.37. In the year 2007, what is the difference between the Total Labor Force (in %) in Costa Rica and Total Labor Force (in %) in Pakistan?
Your response must be concise. -1.3. In the year 2008, what is the difference between the Total Labor Force (in %) of Europe(developing only) and Total Labor Force (in %) of Latin America(developing only)?
Your response must be concise. -10.31. In the year 2008, what is the difference between the Total Labor Force (in %) in Europe(developing only) and Total Labor Force (in %) in Costa Rica?
Provide a short and direct response. -10.35. In the year 2008, what is the difference between the Total Labor Force (in %) of Europe(developing only) and Total Labor Force (in %) of Pakistan?
Your response must be concise. -11.95. In the year 2008, what is the difference between the Total Labor Force (in %) in Latin America(developing only) and Total Labor Force (in %) in Costa Rica?
Offer a terse response. -0.04. In the year 2008, what is the difference between the Total Labor Force (in %) in Latin America(developing only) and Total Labor Force (in %) in Pakistan?
Keep it short and to the point. -1.64. In the year 2008, what is the difference between the Total Labor Force (in %) of Costa Rica and Total Labor Force (in %) of Pakistan?
Ensure brevity in your answer.  -1.6. In the year 2009, what is the difference between the Total Labor Force (in %) of Europe(developing only) and Total Labor Force (in %) of Latin America(developing only)?
Your response must be concise. -9.94. In the year 2009, what is the difference between the Total Labor Force (in %) of Europe(developing only) and Total Labor Force (in %) of Costa Rica?
Your answer should be very brief. -9.36. In the year 2009, what is the difference between the Total Labor Force (in %) of Europe(developing only) and Total Labor Force (in %) of Pakistan?
Your answer should be very brief. -11.86. In the year 2009, what is the difference between the Total Labor Force (in %) of Latin America(developing only) and Total Labor Force (in %) of Costa Rica?
Keep it short and to the point. 0.58. In the year 2009, what is the difference between the Total Labor Force (in %) of Latin America(developing only) and Total Labor Force (in %) of Pakistan?
Provide a short and direct response. -1.92. In the year 2010, what is the difference between the Total Labor Force (in %) in Europe(developing only) and Total Labor Force (in %) in Latin America(developing only)?
Make the answer very short. -9.88. In the year 2010, what is the difference between the Total Labor Force (in %) in Europe(developing only) and Total Labor Force (in %) in Costa Rica?
Provide a short and direct response. -9.28. In the year 2010, what is the difference between the Total Labor Force (in %) in Europe(developing only) and Total Labor Force (in %) in Pakistan?
Give a very brief answer. -11.48. In the year 2010, what is the difference between the Total Labor Force (in %) in Latin America(developing only) and Total Labor Force (in %) in Costa Rica?
Offer a terse response. 0.6. In the year 2010, what is the difference between the Total Labor Force (in %) of Latin America(developing only) and Total Labor Force (in %) of Pakistan?
Offer a terse response. -1.6. In the year 2010, what is the difference between the Total Labor Force (in %) in Costa Rica and Total Labor Force (in %) in Pakistan?
Your answer should be very brief. -2.2. What is the ratio of the Total Labor Force (in %) in Costa Rica in 2003 to that in 2004?
Your answer should be very brief. 1.01. What is the ratio of the Total Labor Force (in %) of Europe(developing only) in 2003 to that in 2005?
Your answer should be very brief. 0.99. What is the ratio of the Total Labor Force (in %) of Pakistan in 2003 to that in 2005?
Your answer should be very brief. 0.99. What is the ratio of the Total Labor Force (in %) in Costa Rica in 2003 to that in 2006?
Give a very brief answer. 1.01. What is the ratio of the Total Labor Force (in %) of Pakistan in 2003 to that in 2006?
Give a very brief answer. 0.99. What is the ratio of the Total Labor Force (in %) in Pakistan in 2003 to that in 2007?
Your response must be concise. 0.99. What is the ratio of the Total Labor Force (in %) of Europe(developing only) in 2003 to that in 2008?
Give a very brief answer. 0.99. What is the ratio of the Total Labor Force (in %) of Costa Rica in 2003 to that in 2008?
Ensure brevity in your answer.  1.01. What is the ratio of the Total Labor Force (in %) in Pakistan in 2003 to that in 2008?
Give a very brief answer. 1. What is the ratio of the Total Labor Force (in %) in Europe(developing only) in 2003 to that in 2009?
Provide a succinct answer. 0.98. What is the ratio of the Total Labor Force (in %) of Costa Rica in 2003 to that in 2009?
Your answer should be compact. 1.02. What is the ratio of the Total Labor Force (in %) in Pakistan in 2003 to that in 2009?
Offer a terse response. 1. What is the ratio of the Total Labor Force (in %) in Europe(developing only) in 2003 to that in 2010?
Ensure brevity in your answer.  0.98. What is the ratio of the Total Labor Force (in %) of Latin America(developing only) in 2003 to that in 2010?
Your answer should be compact. 1. What is the ratio of the Total Labor Force (in %) of Costa Rica in 2003 to that in 2010?
Your answer should be very brief. 1.02. What is the ratio of the Total Labor Force (in %) in Pakistan in 2003 to that in 2010?
Provide a succinct answer. 1. What is the ratio of the Total Labor Force (in %) of Latin America(developing only) in 2004 to that in 2005?
Your answer should be very brief. 1. What is the ratio of the Total Labor Force (in %) of Europe(developing only) in 2004 to that in 2006?
Provide a succinct answer. 1. What is the ratio of the Total Labor Force (in %) of Latin America(developing only) in 2004 to that in 2006?
Offer a very short reply. 1. What is the ratio of the Total Labor Force (in %) in Pakistan in 2004 to that in 2006?
Give a very brief answer. 0.99. What is the ratio of the Total Labor Force (in %) of Europe(developing only) in 2004 to that in 2007?
Make the answer very short. 0.99. What is the ratio of the Total Labor Force (in %) in Latin America(developing only) in 2004 to that in 2007?
Your response must be concise. 1. What is the ratio of the Total Labor Force (in %) in Costa Rica in 2004 to that in 2007?
Give a very brief answer. 0.99. What is the ratio of the Total Labor Force (in %) in Pakistan in 2004 to that in 2007?
Provide a short and direct response. 1. What is the ratio of the Total Labor Force (in %) in Pakistan in 2004 to that in 2008?
Offer a terse response. 1. What is the ratio of the Total Labor Force (in %) in Europe(developing only) in 2004 to that in 2009?
Keep it short and to the point. 0.99. What is the ratio of the Total Labor Force (in %) in Costa Rica in 2004 to that in 2009?
Your answer should be very brief. 1.01. What is the ratio of the Total Labor Force (in %) in Europe(developing only) in 2004 to that in 2010?
Ensure brevity in your answer.  0.99. What is the ratio of the Total Labor Force (in %) of Latin America(developing only) in 2004 to that in 2010?
Your response must be concise. 1. What is the ratio of the Total Labor Force (in %) in Costa Rica in 2005 to that in 2006?
Provide a succinct answer. 1. What is the ratio of the Total Labor Force (in %) of Pakistan in 2005 to that in 2007?
Give a very brief answer. 1. What is the ratio of the Total Labor Force (in %) of Latin America(developing only) in 2005 to that in 2008?
Your answer should be compact. 1. What is the ratio of the Total Labor Force (in %) in Pakistan in 2005 to that in 2008?
Provide a short and direct response. 1.01. What is the ratio of the Total Labor Force (in %) in Europe(developing only) in 2005 to that in 2009?
Provide a succinct answer. 0.99. What is the ratio of the Total Labor Force (in %) of Latin America(developing only) in 2005 to that in 2009?
Your answer should be compact. 1. What is the ratio of the Total Labor Force (in %) in Costa Rica in 2005 to that in 2009?
Your response must be concise. 1.01. What is the ratio of the Total Labor Force (in %) of Latin America(developing only) in 2005 to that in 2010?
Your answer should be very brief. 1. What is the ratio of the Total Labor Force (in %) in Costa Rica in 2005 to that in 2010?
Offer a terse response. 1.01. What is the ratio of the Total Labor Force (in %) of Pakistan in 2005 to that in 2010?
Your answer should be compact. 1.01. What is the ratio of the Total Labor Force (in %) in Latin America(developing only) in 2006 to that in 2007?
Your answer should be very brief. 1. What is the ratio of the Total Labor Force (in %) in Costa Rica in 2006 to that in 2007?
Give a very brief answer. 0.99. What is the ratio of the Total Labor Force (in %) of Pakistan in 2006 to that in 2007?
Your answer should be compact. 1.01. What is the ratio of the Total Labor Force (in %) in Costa Rica in 2006 to that in 2008?
Your response must be concise. 1. What is the ratio of the Total Labor Force (in %) of Pakistan in 2006 to that in 2008?
Ensure brevity in your answer.  1.02. What is the ratio of the Total Labor Force (in %) in Europe(developing only) in 2006 to that in 2009?
Your response must be concise. 0.99. What is the ratio of the Total Labor Force (in %) in Latin America(developing only) in 2006 to that in 2009?
Keep it short and to the point. 1. What is the ratio of the Total Labor Force (in %) of Costa Rica in 2006 to that in 2009?
Give a very brief answer. 1.01. What is the ratio of the Total Labor Force (in %) in Pakistan in 2006 to that in 2009?
Offer a very short reply. 1.02. What is the ratio of the Total Labor Force (in %) in Europe(developing only) in 2006 to that in 2010?
Offer a very short reply. 0.99. What is the ratio of the Total Labor Force (in %) in Costa Rica in 2006 to that in 2010?
Give a very brief answer. 1.01. What is the ratio of the Total Labor Force (in %) in Pakistan in 2006 to that in 2010?
Ensure brevity in your answer.  1.02. What is the ratio of the Total Labor Force (in %) of Latin America(developing only) in 2007 to that in 2008?
Provide a short and direct response. 1. What is the ratio of the Total Labor Force (in %) in Costa Rica in 2007 to that in 2008?
Keep it short and to the point. 1.01. What is the ratio of the Total Labor Force (in %) of Europe(developing only) in 2007 to that in 2009?
Your answer should be very brief. 0.99. What is the ratio of the Total Labor Force (in %) of Costa Rica in 2007 to that in 2009?
Provide a short and direct response. 1.02. What is the ratio of the Total Labor Force (in %) in Europe(developing only) in 2007 to that in 2010?
Keep it short and to the point. 0.99. What is the ratio of the Total Labor Force (in %) of Latin America(developing only) in 2007 to that in 2010?
Give a very brief answer. 1. What is the ratio of the Total Labor Force (in %) in Costa Rica in 2007 to that in 2010?
Offer a terse response. 1.02. What is the ratio of the Total Labor Force (in %) of Pakistan in 2007 to that in 2010?
Offer a very short reply. 1.01. What is the ratio of the Total Labor Force (in %) in Europe(developing only) in 2008 to that in 2009?
Make the answer very short. 1. What is the ratio of the Total Labor Force (in %) of Latin America(developing only) in 2008 to that in 2009?
Make the answer very short. 1. What is the ratio of the Total Labor Force (in %) of Costa Rica in 2008 to that in 2009?
Your answer should be compact. 1.01. What is the ratio of the Total Labor Force (in %) of Pakistan in 2008 to that in 2009?
Give a very brief answer. 1. What is the ratio of the Total Labor Force (in %) in Costa Rica in 2008 to that in 2010?
Your answer should be compact. 1.01. What is the ratio of the Total Labor Force (in %) in Pakistan in 2008 to that in 2010?
Make the answer very short. 1. What is the ratio of the Total Labor Force (in %) of Europe(developing only) in 2009 to that in 2010?
Make the answer very short. 1. What is the ratio of the Total Labor Force (in %) of Costa Rica in 2009 to that in 2010?
Offer a terse response. 1. What is the difference between the highest and the second highest Total Labor Force (in %) in Europe(developing only)?
Make the answer very short. 0.18. What is the difference between the highest and the second highest Total Labor Force (in %) in Latin America(developing only)?
Offer a terse response. 0. What is the difference between the highest and the lowest Total Labor Force (in %) in Europe(developing only)?
Offer a terse response. 1.45. What is the difference between the highest and the lowest Total Labor Force (in %) in Latin America(developing only)?
Make the answer very short. 0.28. 